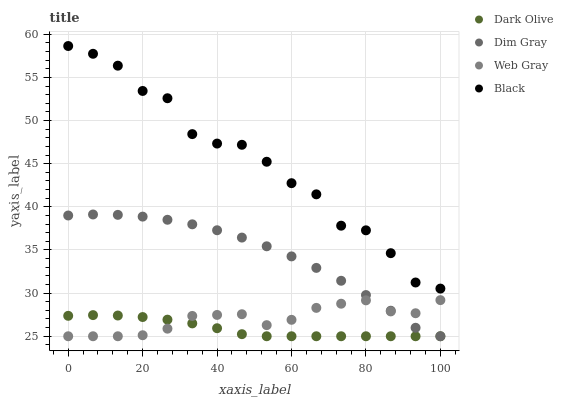Does Dark Olive have the minimum area under the curve?
Answer yes or no. Yes. Does Black have the maximum area under the curve?
Answer yes or no. Yes. Does Dim Gray have the minimum area under the curve?
Answer yes or no. No. Does Dim Gray have the maximum area under the curve?
Answer yes or no. No. Is Dark Olive the smoothest?
Answer yes or no. Yes. Is Black the roughest?
Answer yes or no. Yes. Is Dim Gray the smoothest?
Answer yes or no. No. Is Dim Gray the roughest?
Answer yes or no. No. Does Dim Gray have the lowest value?
Answer yes or no. Yes. Does Black have the highest value?
Answer yes or no. Yes. Does Dim Gray have the highest value?
Answer yes or no. No. Is Web Gray less than Black?
Answer yes or no. Yes. Is Black greater than Dark Olive?
Answer yes or no. Yes. Does Web Gray intersect Dark Olive?
Answer yes or no. Yes. Is Web Gray less than Dark Olive?
Answer yes or no. No. Is Web Gray greater than Dark Olive?
Answer yes or no. No. Does Web Gray intersect Black?
Answer yes or no. No. 